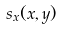Convert formula to latex. <formula><loc_0><loc_0><loc_500><loc_500>s _ { x } ( x , y )</formula> 